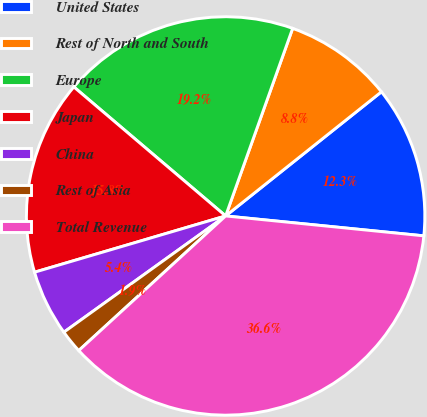<chart> <loc_0><loc_0><loc_500><loc_500><pie_chart><fcel>United States<fcel>Rest of North and South<fcel>Europe<fcel>Japan<fcel>China<fcel>Rest of Asia<fcel>Total Revenue<nl><fcel>12.3%<fcel>8.83%<fcel>19.25%<fcel>15.77%<fcel>5.36%<fcel>1.89%<fcel>36.6%<nl></chart> 